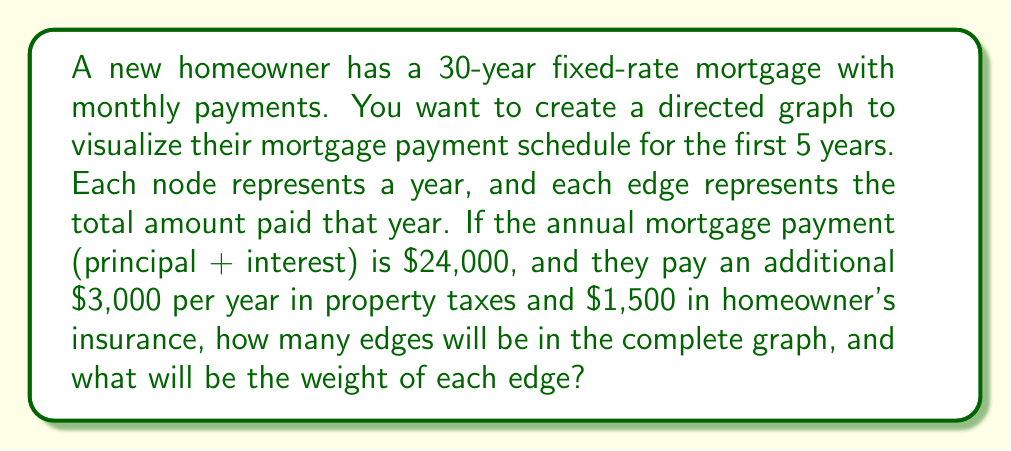What is the answer to this math problem? To solve this problem, let's break it down step by step:

1) First, we need to understand the structure of the graph:
   - Each node represents a year (5 years total)
   - Edges represent the total amount paid each year

2) Calculate the total annual payment:
   $$ \text{Annual Payment} = \text{Mortgage} + \text{Taxes} + \text{Insurance} $$
   $$ \text{Annual Payment} = $24,000 + $3,000 + $1,500 = $28,500 $$

3) In a directed graph representing years, each node will have edges pointing to all future nodes. We can calculate the number of edges using the formula for the sum of the first n-1 natural numbers:
   $$ \text{Number of Edges} = \frac{n(n-1)}{2} $$
   Where n is the number of nodes (years in this case)

4) Substituting n = 5:
   $$ \text{Number of Edges} = \frac{5(5-1)}{2} = \frac{5(4)}{2} = 10 $$

5) Each edge will have a weight of $28,500, representing the total annual payment.

Here's a visualization of the graph:

[asy]
import graph;

size(200);

for(int i=0; i<5; ++i) {
  dot("Year " + string(i+1), (i,0));
}

for(int i=0; i<4; ++i) {
  for(int j=i+1; j<5; ++j) {
    draw((i,0)--(j,0), arrow=Arrow);
  }
}

label("$28,500", (0.5,0.1), N);
[/asy]
Answer: The complete graph will have 10 edges, each with a weight of $28,500. 